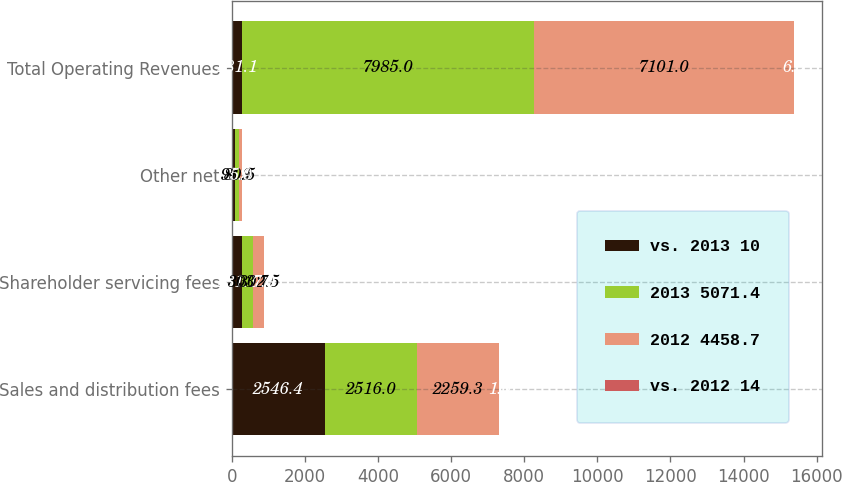Convert chart. <chart><loc_0><loc_0><loc_500><loc_500><stacked_bar_chart><ecel><fcel>Sales and distribution fees<fcel>Shareholder servicing fees<fcel>Other net<fcel>Total Operating Revenues<nl><fcel>vs. 2013 10<fcel>2546.4<fcel>281.1<fcel>98.2<fcel>281.1<nl><fcel>2013 5071.4<fcel>2516<fcel>303.7<fcel>93.9<fcel>7985<nl><fcel>2012 4458.7<fcel>2259.3<fcel>302.5<fcel>80.5<fcel>7101<nl><fcel>vs. 2012 14<fcel>1<fcel>7<fcel>5<fcel>6<nl></chart> 